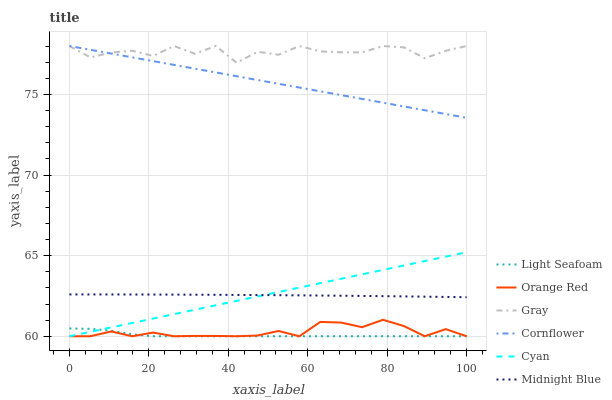Does Light Seafoam have the minimum area under the curve?
Answer yes or no. Yes. Does Gray have the maximum area under the curve?
Answer yes or no. Yes. Does Midnight Blue have the minimum area under the curve?
Answer yes or no. No. Does Midnight Blue have the maximum area under the curve?
Answer yes or no. No. Is Cornflower the smoothest?
Answer yes or no. Yes. Is Gray the roughest?
Answer yes or no. Yes. Is Midnight Blue the smoothest?
Answer yes or no. No. Is Midnight Blue the roughest?
Answer yes or no. No. Does Cyan have the lowest value?
Answer yes or no. Yes. Does Midnight Blue have the lowest value?
Answer yes or no. No. Does Cornflower have the highest value?
Answer yes or no. Yes. Does Midnight Blue have the highest value?
Answer yes or no. No. Is Orange Red less than Midnight Blue?
Answer yes or no. Yes. Is Midnight Blue greater than Light Seafoam?
Answer yes or no. Yes. Does Cyan intersect Orange Red?
Answer yes or no. Yes. Is Cyan less than Orange Red?
Answer yes or no. No. Is Cyan greater than Orange Red?
Answer yes or no. No. Does Orange Red intersect Midnight Blue?
Answer yes or no. No. 